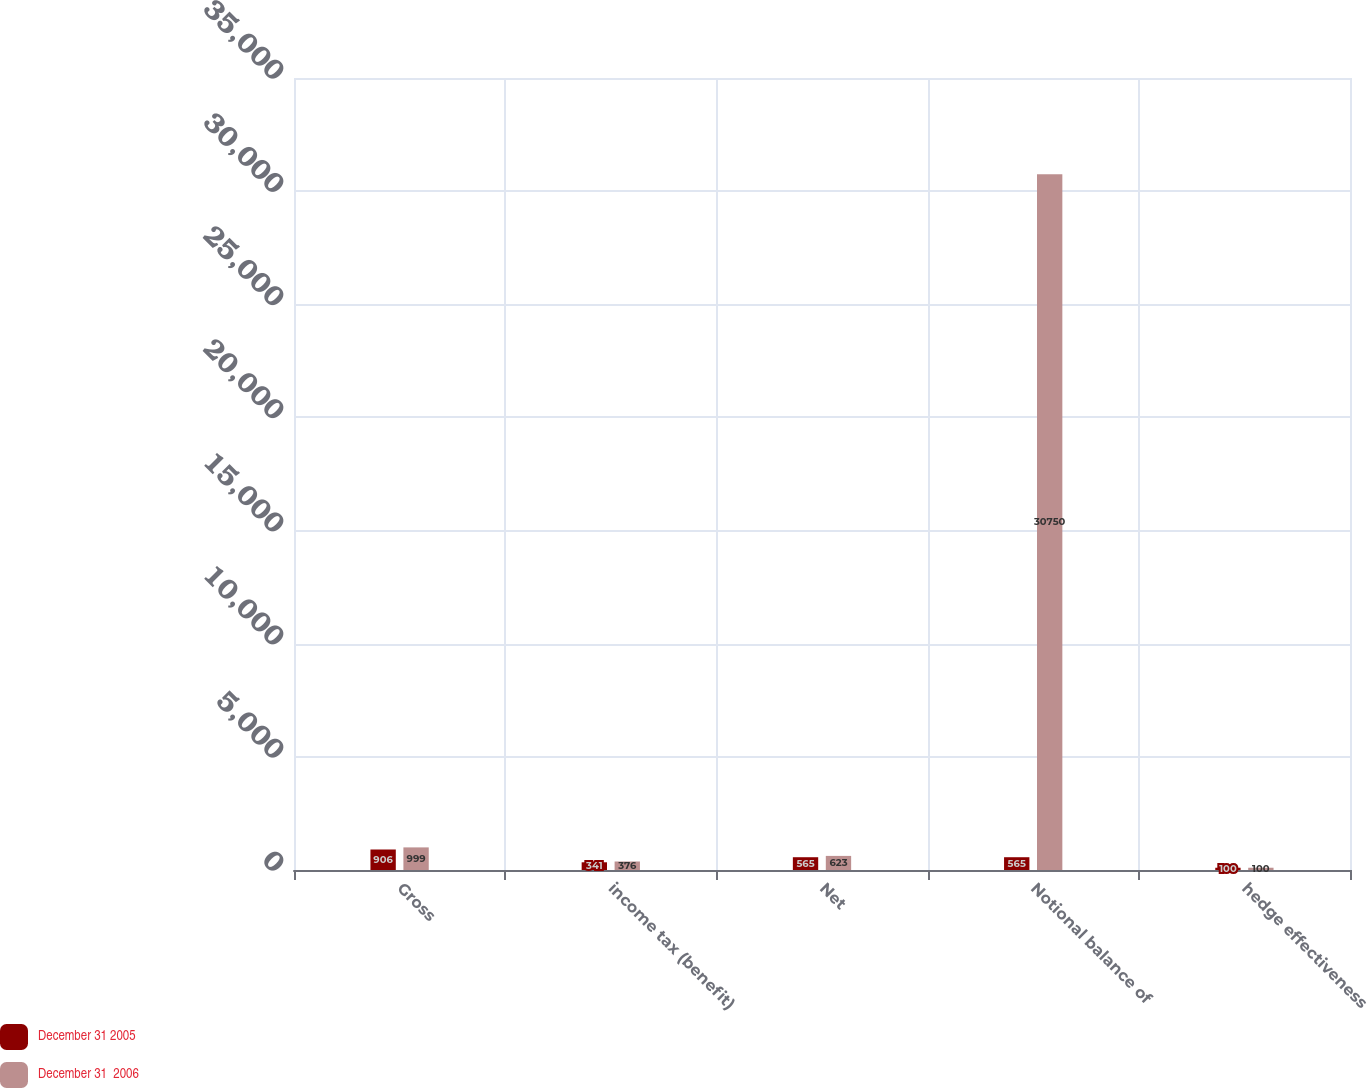Convert chart to OTSL. <chart><loc_0><loc_0><loc_500><loc_500><stacked_bar_chart><ecel><fcel>Gross<fcel>income tax (benefit)<fcel>Net<fcel>Notional balance of<fcel>hedge effectiveness<nl><fcel>December 31 2005<fcel>906<fcel>341<fcel>565<fcel>565<fcel>100<nl><fcel>December 31  2006<fcel>999<fcel>376<fcel>623<fcel>30750<fcel>100<nl></chart> 